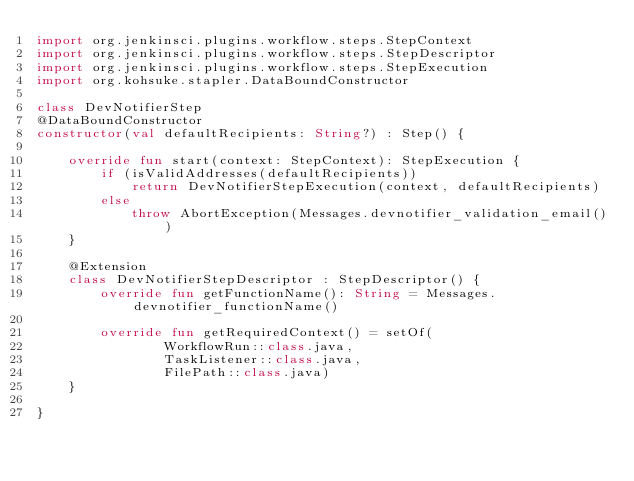<code> <loc_0><loc_0><loc_500><loc_500><_Kotlin_>import org.jenkinsci.plugins.workflow.steps.StepContext
import org.jenkinsci.plugins.workflow.steps.StepDescriptor
import org.jenkinsci.plugins.workflow.steps.StepExecution
import org.kohsuke.stapler.DataBoundConstructor

class DevNotifierStep
@DataBoundConstructor
constructor(val defaultRecipients: String?) : Step() {

    override fun start(context: StepContext): StepExecution {
        if (isValidAddresses(defaultRecipients))
            return DevNotifierStepExecution(context, defaultRecipients)
        else
            throw AbortException(Messages.devnotifier_validation_email())
    }

    @Extension
    class DevNotifierStepDescriptor : StepDescriptor() {
        override fun getFunctionName(): String = Messages.devnotifier_functionName()

        override fun getRequiredContext() = setOf(
                WorkflowRun::class.java,
                TaskListener::class.java,
                FilePath::class.java)
    }

}
</code> 